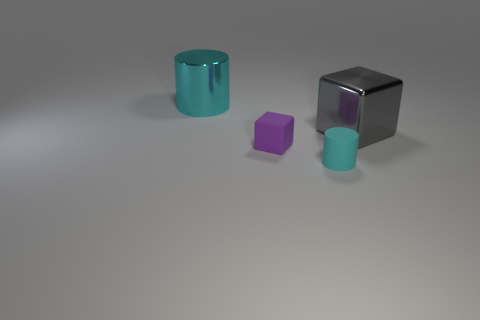There is a thing that is both behind the cyan rubber cylinder and to the right of the small purple rubber cube; what is its size?
Make the answer very short. Large. Is the color of the cylinder that is behind the tiny cylinder the same as the small matte cylinder?
Provide a succinct answer. Yes. There is a metal cylinder that is the same color as the tiny matte cylinder; what is its size?
Make the answer very short. Large. There is a tiny object that is on the left side of the small cyan cylinder; is there a large cyan cylinder that is on the left side of it?
Provide a succinct answer. Yes. Does the large metallic object to the right of the large cyan cylinder have the same shape as the cyan rubber object?
Provide a short and direct response. No. What is the shape of the cyan matte object?
Your answer should be compact. Cylinder. How many tiny cyan cylinders are the same material as the large gray object?
Offer a very short reply. 0. There is a big shiny cylinder; is its color the same as the tiny object in front of the purple cube?
Your response must be concise. Yes. How many cyan shiny cylinders are there?
Your answer should be compact. 1. Are there any other cylinders that have the same color as the big cylinder?
Your response must be concise. Yes. 